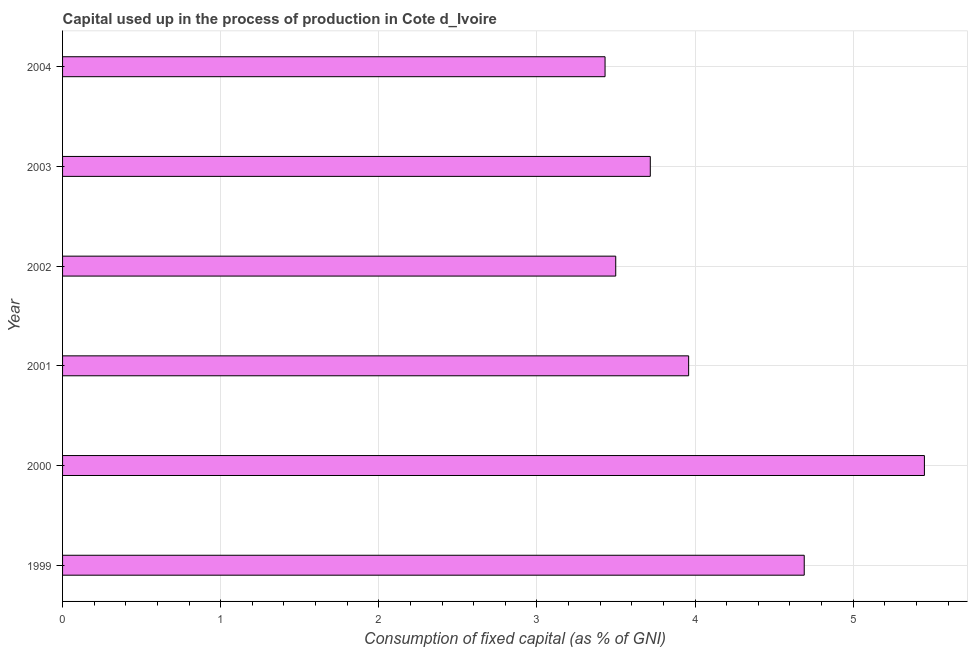Does the graph contain grids?
Keep it short and to the point. Yes. What is the title of the graph?
Offer a very short reply. Capital used up in the process of production in Cote d_Ivoire. What is the label or title of the X-axis?
Offer a very short reply. Consumption of fixed capital (as % of GNI). What is the consumption of fixed capital in 1999?
Make the answer very short. 4.69. Across all years, what is the maximum consumption of fixed capital?
Give a very brief answer. 5.45. Across all years, what is the minimum consumption of fixed capital?
Give a very brief answer. 3.43. What is the sum of the consumption of fixed capital?
Your answer should be compact. 24.75. What is the difference between the consumption of fixed capital in 1999 and 2002?
Make the answer very short. 1.19. What is the average consumption of fixed capital per year?
Make the answer very short. 4.12. What is the median consumption of fixed capital?
Provide a succinct answer. 3.84. In how many years, is the consumption of fixed capital greater than 0.8 %?
Give a very brief answer. 6. Do a majority of the years between 1999 and 2004 (inclusive) have consumption of fixed capital greater than 0.4 %?
Give a very brief answer. Yes. What is the ratio of the consumption of fixed capital in 2002 to that in 2003?
Your answer should be compact. 0.94. What is the difference between the highest and the second highest consumption of fixed capital?
Make the answer very short. 0.76. Is the sum of the consumption of fixed capital in 2002 and 2003 greater than the maximum consumption of fixed capital across all years?
Make the answer very short. Yes. What is the difference between the highest and the lowest consumption of fixed capital?
Ensure brevity in your answer.  2.02. How many years are there in the graph?
Keep it short and to the point. 6. What is the Consumption of fixed capital (as % of GNI) in 1999?
Offer a very short reply. 4.69. What is the Consumption of fixed capital (as % of GNI) of 2000?
Provide a succinct answer. 5.45. What is the Consumption of fixed capital (as % of GNI) of 2001?
Make the answer very short. 3.96. What is the Consumption of fixed capital (as % of GNI) of 2002?
Make the answer very short. 3.5. What is the Consumption of fixed capital (as % of GNI) in 2003?
Keep it short and to the point. 3.72. What is the Consumption of fixed capital (as % of GNI) of 2004?
Your answer should be very brief. 3.43. What is the difference between the Consumption of fixed capital (as % of GNI) in 1999 and 2000?
Provide a succinct answer. -0.76. What is the difference between the Consumption of fixed capital (as % of GNI) in 1999 and 2001?
Ensure brevity in your answer.  0.73. What is the difference between the Consumption of fixed capital (as % of GNI) in 1999 and 2002?
Your answer should be compact. 1.19. What is the difference between the Consumption of fixed capital (as % of GNI) in 1999 and 2003?
Offer a very short reply. 0.97. What is the difference between the Consumption of fixed capital (as % of GNI) in 1999 and 2004?
Give a very brief answer. 1.26. What is the difference between the Consumption of fixed capital (as % of GNI) in 2000 and 2001?
Offer a terse response. 1.49. What is the difference between the Consumption of fixed capital (as % of GNI) in 2000 and 2002?
Provide a succinct answer. 1.95. What is the difference between the Consumption of fixed capital (as % of GNI) in 2000 and 2003?
Offer a terse response. 1.73. What is the difference between the Consumption of fixed capital (as % of GNI) in 2000 and 2004?
Ensure brevity in your answer.  2.02. What is the difference between the Consumption of fixed capital (as % of GNI) in 2001 and 2002?
Your response must be concise. 0.46. What is the difference between the Consumption of fixed capital (as % of GNI) in 2001 and 2003?
Offer a terse response. 0.24. What is the difference between the Consumption of fixed capital (as % of GNI) in 2001 and 2004?
Ensure brevity in your answer.  0.53. What is the difference between the Consumption of fixed capital (as % of GNI) in 2002 and 2003?
Your response must be concise. -0.22. What is the difference between the Consumption of fixed capital (as % of GNI) in 2002 and 2004?
Keep it short and to the point. 0.07. What is the difference between the Consumption of fixed capital (as % of GNI) in 2003 and 2004?
Provide a short and direct response. 0.29. What is the ratio of the Consumption of fixed capital (as % of GNI) in 1999 to that in 2000?
Provide a succinct answer. 0.86. What is the ratio of the Consumption of fixed capital (as % of GNI) in 1999 to that in 2001?
Offer a terse response. 1.19. What is the ratio of the Consumption of fixed capital (as % of GNI) in 1999 to that in 2002?
Offer a terse response. 1.34. What is the ratio of the Consumption of fixed capital (as % of GNI) in 1999 to that in 2003?
Provide a short and direct response. 1.26. What is the ratio of the Consumption of fixed capital (as % of GNI) in 1999 to that in 2004?
Keep it short and to the point. 1.37. What is the ratio of the Consumption of fixed capital (as % of GNI) in 2000 to that in 2001?
Your response must be concise. 1.38. What is the ratio of the Consumption of fixed capital (as % of GNI) in 2000 to that in 2002?
Your answer should be very brief. 1.56. What is the ratio of the Consumption of fixed capital (as % of GNI) in 2000 to that in 2003?
Offer a very short reply. 1.47. What is the ratio of the Consumption of fixed capital (as % of GNI) in 2000 to that in 2004?
Make the answer very short. 1.59. What is the ratio of the Consumption of fixed capital (as % of GNI) in 2001 to that in 2002?
Your answer should be very brief. 1.13. What is the ratio of the Consumption of fixed capital (as % of GNI) in 2001 to that in 2003?
Your response must be concise. 1.06. What is the ratio of the Consumption of fixed capital (as % of GNI) in 2001 to that in 2004?
Offer a terse response. 1.15. What is the ratio of the Consumption of fixed capital (as % of GNI) in 2002 to that in 2003?
Your answer should be compact. 0.94. What is the ratio of the Consumption of fixed capital (as % of GNI) in 2003 to that in 2004?
Ensure brevity in your answer.  1.08. 